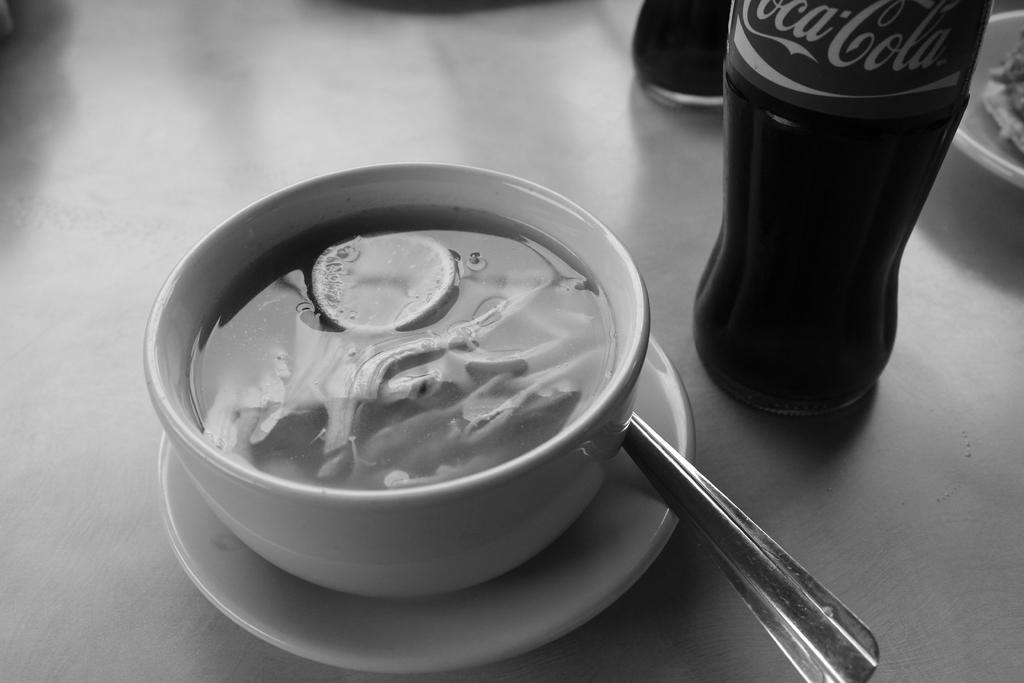Provide a one-sentence caption for the provided image. A bottle of Coca-Cola is next to a white bowl filled with a thick creamy looking soup. 